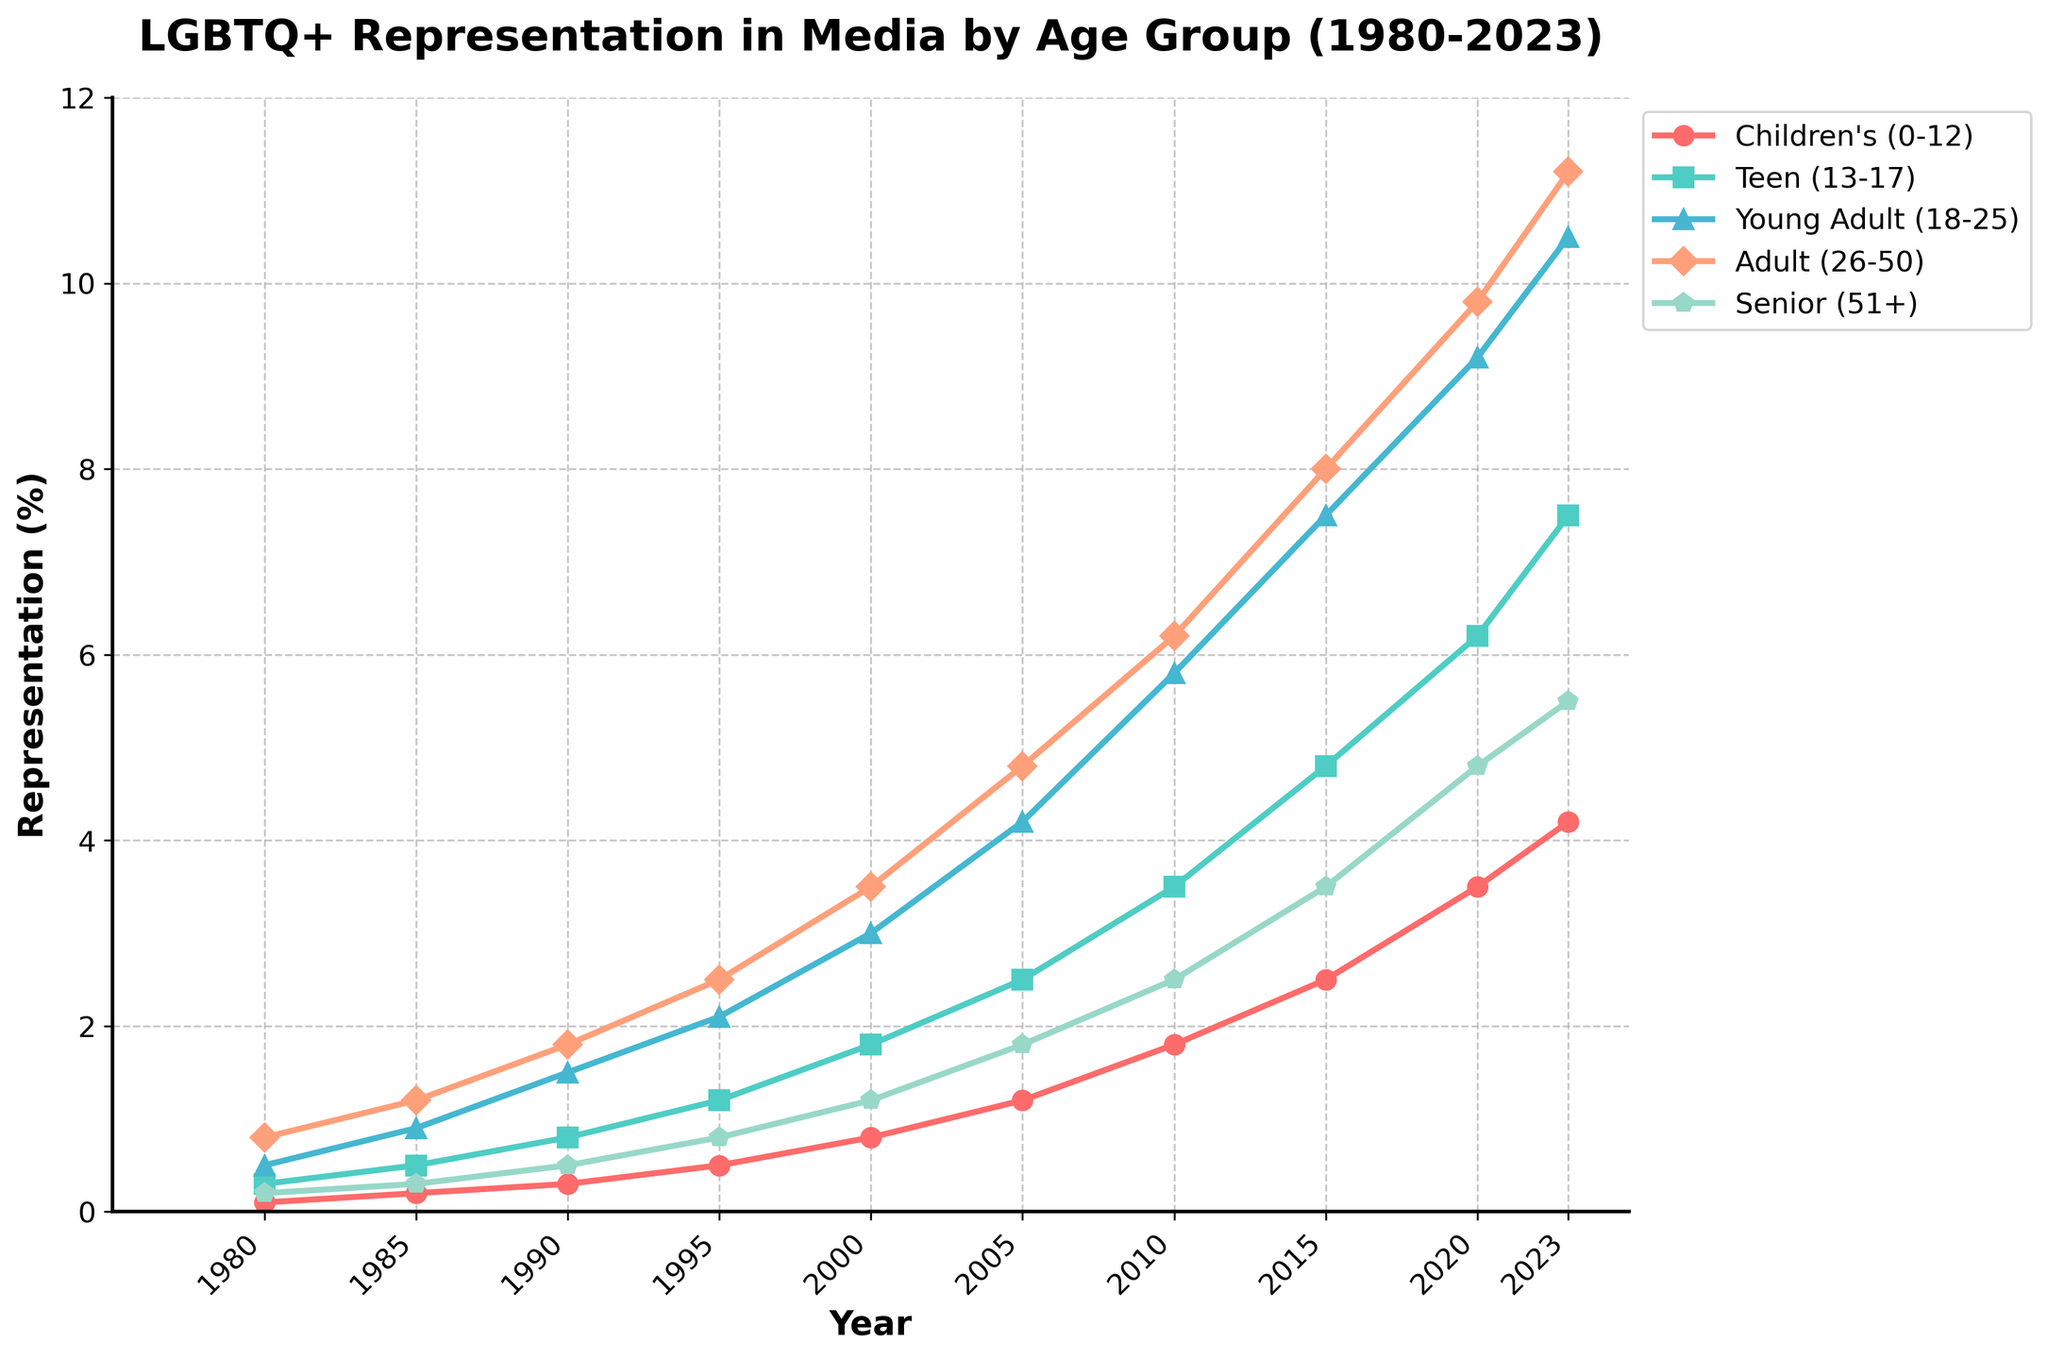Which age group has the highest representation of LGBTQ+ characters in 2023? By looking at the figure, the Young Adult group has the highest representation in 2023.
Answer: Young Adult (18-25) How much did the representation for the Teen group increase from 1980 to 2023? In 1980, the representation for the Teen group was 0.3%. In 2023, it increased to 7.5%. The difference is 7.5% - 0.3% = 7.2%.
Answer: 7.2% By how much did the LGBTQ+ representation for Adults (26-50) change between 2000 and 2010? The representation for Adults in 2000 was 3.5%, and in 2010, it was 6.2%. The change is 6.2% - 3.5% = 2.7%.
Answer: 2.7% Which age group had the smallest increase in LGBTQ+ representation from 1980 to 2023? By comparing the increase for all age groups from 1980 to 2023, the Senior group (51+) had the smallest increase, going from 0.2% to 5.5%, which is an increase of 5.3%.
Answer: Senior (51+) What is the total LGBTQ+ representation across all age groups in the year 2005? In 2005, the values are: 1.2% (Children’s), 2.5% (Teen), 4.2% (Young Adult), 4.8% (Adult), 1.8% (Senior). The total is 1.2 + 2.5 + 4.2 + 4.8 + 1.8 = 14.5%.
Answer: 14.5% Which age group saw the greatest absolute change in representation between 2015 and 2023? In 2015, the values are: 2.5% (Children’s), 4.8% (Teen), 7.5% (Young Adult), 8.0% (Adult), 3.5% (Senior). In 2023, the values are: 4.2% (Children’s), 7.5% (Teen), 10.5% (Young Adult), 11.2% (Adult), 5.5% (Senior). The greatest absolute change is for the Young Adult group, 10.5% - 7.5% = 3.0%.
Answer: Young Adult (18-25) By observing the color and pattern of the lines, which group’s representation line is represented by the red line? The red line represents the Children's (0-12) group.
Answer: Children's (0-12) In which year did the young adult group's representation surpass 5%? By examining the figure, the Young Adult group surpassed 5% around the year 2005.
Answer: 2005 Which two age groups had the closest representation percentages in 2020? In 2020, the values are: 3.5% (Children’s), 6.2% (Teen), 9.2% (Young Adult), 9.8% (Adult), 4.8% (Senior). The closest percentages are for Young Adult and Adult, with 9.2% and 9.8%, respectively.
Answer: Young Adult (18-25), Adult (26-50) Between which consecutive years did the Teen group's representation see the greatest increase? By comparing each consecutive interval for the Teen group: 1980-1985 (0.3% to 0.5%), 1985-1990 (0.5% to 0.8%), 1990-1995 (0.8% to 1.2%), 1995-2000 (1.2% to 1.8%), 2000-2005 (1.8% to 2.5%), 2005-2010 (2.5% to 3.5%), 2010-2015 (3.5% to 4.8%), 2015-2020 (4.8% to 6.2%), 2020-2023 (6.2% to 7.5%). The greatest increase is from 2015 to 2020 with an increase of 1.4%.
Answer: 2015-2020 